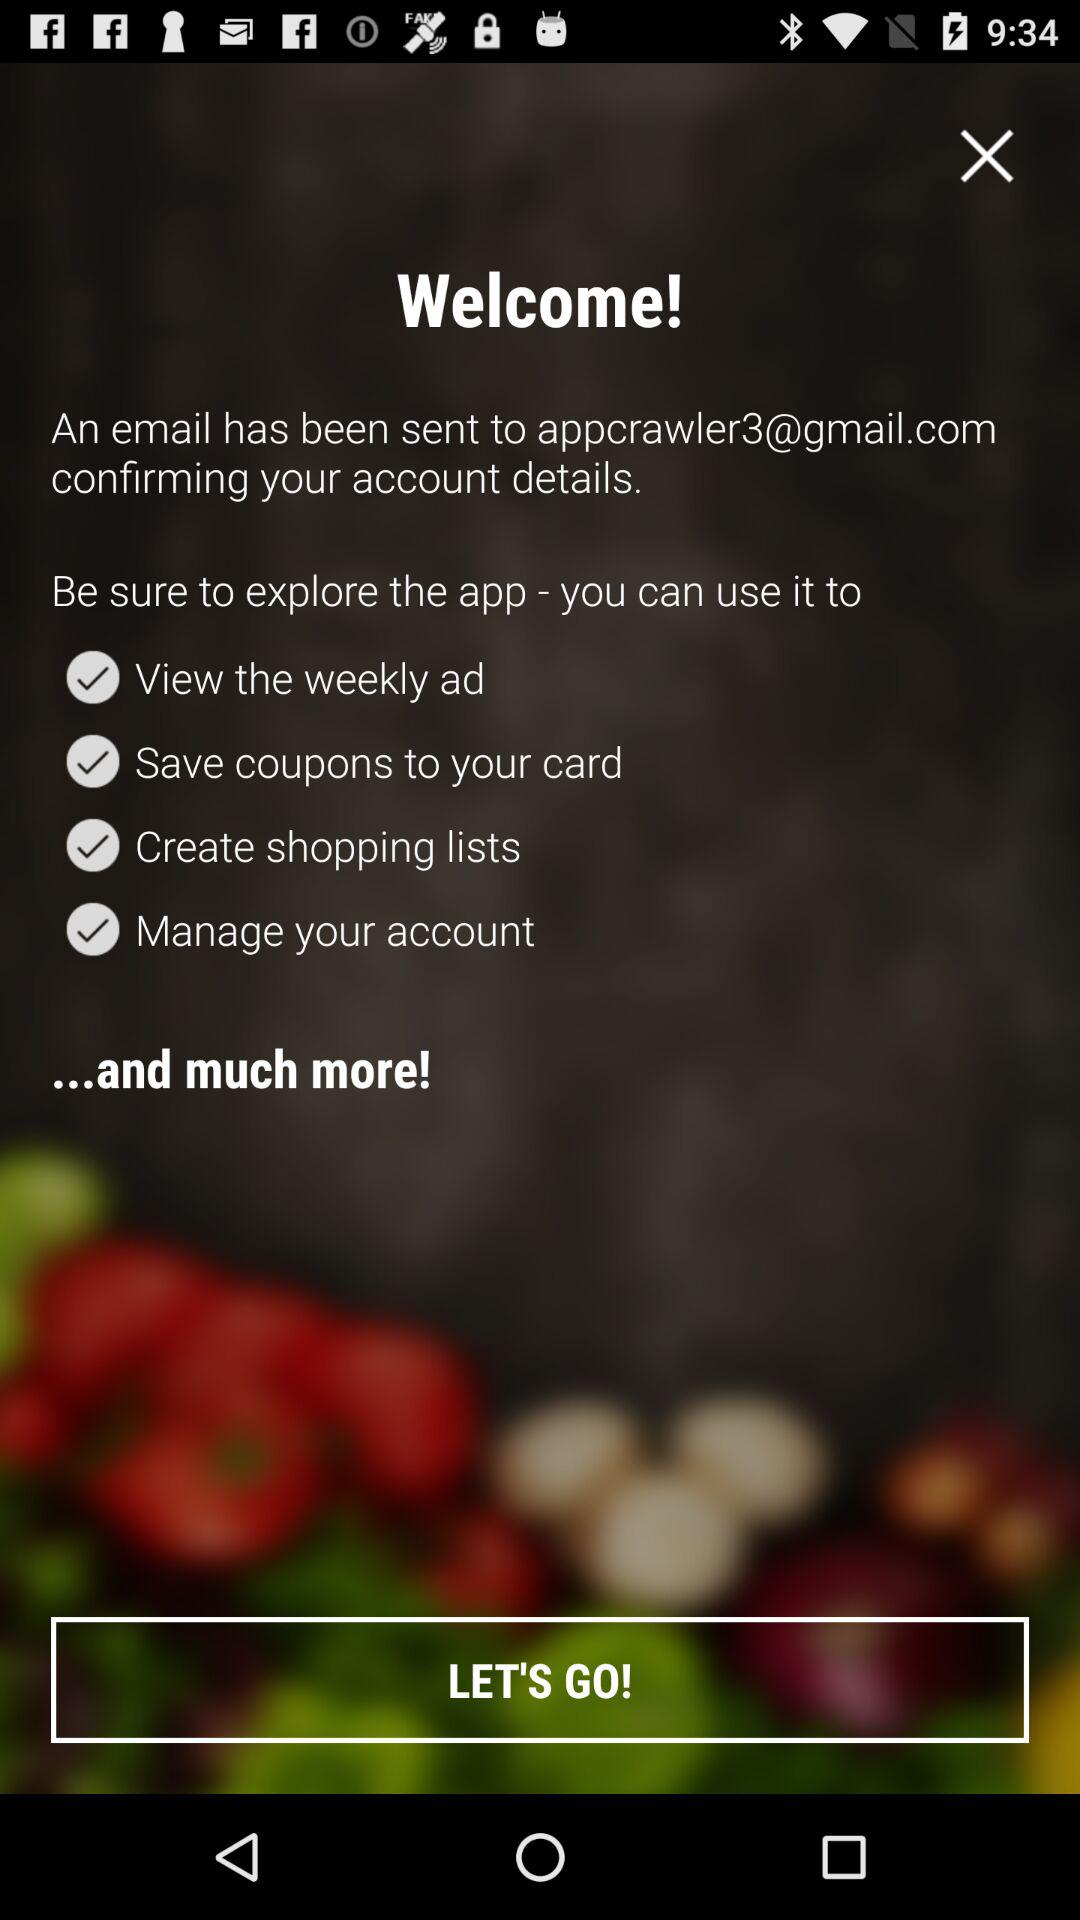What is the email address? The email address is appcrawler3@gmail.com. 